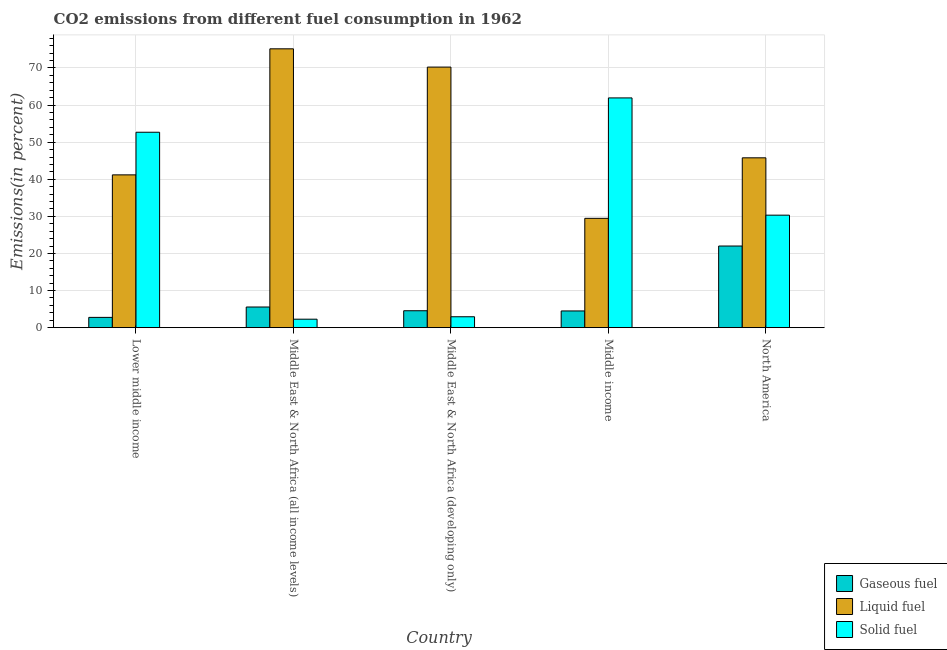How many groups of bars are there?
Your answer should be very brief. 5. Are the number of bars on each tick of the X-axis equal?
Give a very brief answer. Yes. How many bars are there on the 3rd tick from the left?
Provide a short and direct response. 3. What is the label of the 4th group of bars from the left?
Make the answer very short. Middle income. In how many cases, is the number of bars for a given country not equal to the number of legend labels?
Your answer should be compact. 0. What is the percentage of liquid fuel emission in Lower middle income?
Offer a terse response. 41.19. Across all countries, what is the maximum percentage of gaseous fuel emission?
Your answer should be very brief. 22. Across all countries, what is the minimum percentage of gaseous fuel emission?
Make the answer very short. 2.77. In which country was the percentage of solid fuel emission minimum?
Provide a short and direct response. Middle East & North Africa (all income levels). What is the total percentage of liquid fuel emission in the graph?
Offer a very short reply. 261.83. What is the difference between the percentage of solid fuel emission in Lower middle income and that in Middle East & North Africa (all income levels)?
Your response must be concise. 50.39. What is the difference between the percentage of liquid fuel emission in Middle income and the percentage of solid fuel emission in Middle East & North Africa (all income levels)?
Provide a succinct answer. 27.18. What is the average percentage of solid fuel emission per country?
Keep it short and to the point. 30.03. What is the difference between the percentage of solid fuel emission and percentage of gaseous fuel emission in Lower middle income?
Offer a very short reply. 49.9. What is the ratio of the percentage of solid fuel emission in Lower middle income to that in Middle income?
Offer a very short reply. 0.85. Is the difference between the percentage of solid fuel emission in Middle income and North America greater than the difference between the percentage of liquid fuel emission in Middle income and North America?
Keep it short and to the point. Yes. What is the difference between the highest and the second highest percentage of liquid fuel emission?
Your answer should be compact. 4.92. What is the difference between the highest and the lowest percentage of liquid fuel emission?
Your answer should be compact. 45.69. Is the sum of the percentage of liquid fuel emission in Lower middle income and Middle income greater than the maximum percentage of solid fuel emission across all countries?
Offer a very short reply. Yes. What does the 2nd bar from the left in Lower middle income represents?
Your answer should be very brief. Liquid fuel. What does the 2nd bar from the right in Middle income represents?
Your response must be concise. Liquid fuel. Is it the case that in every country, the sum of the percentage of gaseous fuel emission and percentage of liquid fuel emission is greater than the percentage of solid fuel emission?
Make the answer very short. No. What is the difference between two consecutive major ticks on the Y-axis?
Offer a very short reply. 10. Does the graph contain any zero values?
Ensure brevity in your answer.  No. Where does the legend appear in the graph?
Your answer should be very brief. Bottom right. How many legend labels are there?
Offer a very short reply. 3. What is the title of the graph?
Provide a succinct answer. CO2 emissions from different fuel consumption in 1962. Does "Ages 20-60" appear as one of the legend labels in the graph?
Your answer should be compact. No. What is the label or title of the X-axis?
Your answer should be compact. Country. What is the label or title of the Y-axis?
Keep it short and to the point. Emissions(in percent). What is the Emissions(in percent) in Gaseous fuel in Lower middle income?
Offer a terse response. 2.77. What is the Emissions(in percent) of Liquid fuel in Lower middle income?
Make the answer very short. 41.19. What is the Emissions(in percent) in Solid fuel in Lower middle income?
Your answer should be compact. 52.67. What is the Emissions(in percent) in Gaseous fuel in Middle East & North Africa (all income levels)?
Provide a succinct answer. 5.57. What is the Emissions(in percent) in Liquid fuel in Middle East & North Africa (all income levels)?
Your response must be concise. 75.16. What is the Emissions(in percent) of Solid fuel in Middle East & North Africa (all income levels)?
Keep it short and to the point. 2.28. What is the Emissions(in percent) of Gaseous fuel in Middle East & North Africa (developing only)?
Your response must be concise. 4.56. What is the Emissions(in percent) of Liquid fuel in Middle East & North Africa (developing only)?
Provide a short and direct response. 70.23. What is the Emissions(in percent) in Solid fuel in Middle East & North Africa (developing only)?
Give a very brief answer. 2.94. What is the Emissions(in percent) of Gaseous fuel in Middle income?
Provide a succinct answer. 4.5. What is the Emissions(in percent) in Liquid fuel in Middle income?
Your answer should be compact. 29.47. What is the Emissions(in percent) of Solid fuel in Middle income?
Provide a short and direct response. 61.92. What is the Emissions(in percent) in Gaseous fuel in North America?
Ensure brevity in your answer.  22. What is the Emissions(in percent) of Liquid fuel in North America?
Ensure brevity in your answer.  45.78. What is the Emissions(in percent) of Solid fuel in North America?
Your response must be concise. 30.32. Across all countries, what is the maximum Emissions(in percent) of Gaseous fuel?
Make the answer very short. 22. Across all countries, what is the maximum Emissions(in percent) of Liquid fuel?
Offer a very short reply. 75.16. Across all countries, what is the maximum Emissions(in percent) of Solid fuel?
Offer a terse response. 61.92. Across all countries, what is the minimum Emissions(in percent) in Gaseous fuel?
Provide a short and direct response. 2.77. Across all countries, what is the minimum Emissions(in percent) in Liquid fuel?
Provide a short and direct response. 29.47. Across all countries, what is the minimum Emissions(in percent) in Solid fuel?
Make the answer very short. 2.28. What is the total Emissions(in percent) of Gaseous fuel in the graph?
Give a very brief answer. 39.41. What is the total Emissions(in percent) of Liquid fuel in the graph?
Provide a succinct answer. 261.83. What is the total Emissions(in percent) of Solid fuel in the graph?
Your answer should be compact. 150.14. What is the difference between the Emissions(in percent) in Gaseous fuel in Lower middle income and that in Middle East & North Africa (all income levels)?
Your answer should be compact. -2.8. What is the difference between the Emissions(in percent) in Liquid fuel in Lower middle income and that in Middle East & North Africa (all income levels)?
Make the answer very short. -33.97. What is the difference between the Emissions(in percent) in Solid fuel in Lower middle income and that in Middle East & North Africa (all income levels)?
Make the answer very short. 50.39. What is the difference between the Emissions(in percent) of Gaseous fuel in Lower middle income and that in Middle East & North Africa (developing only)?
Provide a short and direct response. -1.79. What is the difference between the Emissions(in percent) of Liquid fuel in Lower middle income and that in Middle East & North Africa (developing only)?
Give a very brief answer. -29.05. What is the difference between the Emissions(in percent) in Solid fuel in Lower middle income and that in Middle East & North Africa (developing only)?
Ensure brevity in your answer.  49.73. What is the difference between the Emissions(in percent) of Gaseous fuel in Lower middle income and that in Middle income?
Keep it short and to the point. -1.73. What is the difference between the Emissions(in percent) in Liquid fuel in Lower middle income and that in Middle income?
Provide a succinct answer. 11.72. What is the difference between the Emissions(in percent) of Solid fuel in Lower middle income and that in Middle income?
Your answer should be compact. -9.25. What is the difference between the Emissions(in percent) of Gaseous fuel in Lower middle income and that in North America?
Your answer should be compact. -19.23. What is the difference between the Emissions(in percent) in Liquid fuel in Lower middle income and that in North America?
Provide a short and direct response. -4.59. What is the difference between the Emissions(in percent) of Solid fuel in Lower middle income and that in North America?
Offer a very short reply. 22.35. What is the difference between the Emissions(in percent) in Gaseous fuel in Middle East & North Africa (all income levels) and that in Middle East & North Africa (developing only)?
Ensure brevity in your answer.  1.01. What is the difference between the Emissions(in percent) in Liquid fuel in Middle East & North Africa (all income levels) and that in Middle East & North Africa (developing only)?
Provide a succinct answer. 4.92. What is the difference between the Emissions(in percent) in Solid fuel in Middle East & North Africa (all income levels) and that in Middle East & North Africa (developing only)?
Your answer should be compact. -0.65. What is the difference between the Emissions(in percent) of Gaseous fuel in Middle East & North Africa (all income levels) and that in Middle income?
Give a very brief answer. 1.06. What is the difference between the Emissions(in percent) of Liquid fuel in Middle East & North Africa (all income levels) and that in Middle income?
Provide a short and direct response. 45.69. What is the difference between the Emissions(in percent) of Solid fuel in Middle East & North Africa (all income levels) and that in Middle income?
Your answer should be very brief. -59.64. What is the difference between the Emissions(in percent) in Gaseous fuel in Middle East & North Africa (all income levels) and that in North America?
Give a very brief answer. -16.44. What is the difference between the Emissions(in percent) in Liquid fuel in Middle East & North Africa (all income levels) and that in North America?
Keep it short and to the point. 29.38. What is the difference between the Emissions(in percent) in Solid fuel in Middle East & North Africa (all income levels) and that in North America?
Ensure brevity in your answer.  -28.04. What is the difference between the Emissions(in percent) in Gaseous fuel in Middle East & North Africa (developing only) and that in Middle income?
Keep it short and to the point. 0.06. What is the difference between the Emissions(in percent) in Liquid fuel in Middle East & North Africa (developing only) and that in Middle income?
Offer a terse response. 40.77. What is the difference between the Emissions(in percent) in Solid fuel in Middle East & North Africa (developing only) and that in Middle income?
Offer a very short reply. -58.99. What is the difference between the Emissions(in percent) in Gaseous fuel in Middle East & North Africa (developing only) and that in North America?
Offer a very short reply. -17.44. What is the difference between the Emissions(in percent) in Liquid fuel in Middle East & North Africa (developing only) and that in North America?
Your response must be concise. 24.46. What is the difference between the Emissions(in percent) of Solid fuel in Middle East & North Africa (developing only) and that in North America?
Give a very brief answer. -27.38. What is the difference between the Emissions(in percent) in Gaseous fuel in Middle income and that in North America?
Offer a terse response. -17.5. What is the difference between the Emissions(in percent) in Liquid fuel in Middle income and that in North America?
Provide a short and direct response. -16.31. What is the difference between the Emissions(in percent) of Solid fuel in Middle income and that in North America?
Your answer should be very brief. 31.6. What is the difference between the Emissions(in percent) in Gaseous fuel in Lower middle income and the Emissions(in percent) in Liquid fuel in Middle East & North Africa (all income levels)?
Keep it short and to the point. -72.39. What is the difference between the Emissions(in percent) in Gaseous fuel in Lower middle income and the Emissions(in percent) in Solid fuel in Middle East & North Africa (all income levels)?
Your answer should be very brief. 0.49. What is the difference between the Emissions(in percent) in Liquid fuel in Lower middle income and the Emissions(in percent) in Solid fuel in Middle East & North Africa (all income levels)?
Your answer should be compact. 38.9. What is the difference between the Emissions(in percent) of Gaseous fuel in Lower middle income and the Emissions(in percent) of Liquid fuel in Middle East & North Africa (developing only)?
Make the answer very short. -67.46. What is the difference between the Emissions(in percent) of Gaseous fuel in Lower middle income and the Emissions(in percent) of Solid fuel in Middle East & North Africa (developing only)?
Ensure brevity in your answer.  -0.17. What is the difference between the Emissions(in percent) in Liquid fuel in Lower middle income and the Emissions(in percent) in Solid fuel in Middle East & North Africa (developing only)?
Give a very brief answer. 38.25. What is the difference between the Emissions(in percent) of Gaseous fuel in Lower middle income and the Emissions(in percent) of Liquid fuel in Middle income?
Offer a terse response. -26.7. What is the difference between the Emissions(in percent) of Gaseous fuel in Lower middle income and the Emissions(in percent) of Solid fuel in Middle income?
Offer a terse response. -59.15. What is the difference between the Emissions(in percent) of Liquid fuel in Lower middle income and the Emissions(in percent) of Solid fuel in Middle income?
Provide a succinct answer. -20.74. What is the difference between the Emissions(in percent) of Gaseous fuel in Lower middle income and the Emissions(in percent) of Liquid fuel in North America?
Give a very brief answer. -43.01. What is the difference between the Emissions(in percent) of Gaseous fuel in Lower middle income and the Emissions(in percent) of Solid fuel in North America?
Give a very brief answer. -27.55. What is the difference between the Emissions(in percent) in Liquid fuel in Lower middle income and the Emissions(in percent) in Solid fuel in North America?
Offer a terse response. 10.86. What is the difference between the Emissions(in percent) of Gaseous fuel in Middle East & North Africa (all income levels) and the Emissions(in percent) of Liquid fuel in Middle East & North Africa (developing only)?
Your response must be concise. -64.67. What is the difference between the Emissions(in percent) of Gaseous fuel in Middle East & North Africa (all income levels) and the Emissions(in percent) of Solid fuel in Middle East & North Africa (developing only)?
Offer a very short reply. 2.63. What is the difference between the Emissions(in percent) of Liquid fuel in Middle East & North Africa (all income levels) and the Emissions(in percent) of Solid fuel in Middle East & North Africa (developing only)?
Your answer should be very brief. 72.22. What is the difference between the Emissions(in percent) in Gaseous fuel in Middle East & North Africa (all income levels) and the Emissions(in percent) in Liquid fuel in Middle income?
Give a very brief answer. -23.9. What is the difference between the Emissions(in percent) of Gaseous fuel in Middle East & North Africa (all income levels) and the Emissions(in percent) of Solid fuel in Middle income?
Your response must be concise. -56.36. What is the difference between the Emissions(in percent) in Liquid fuel in Middle East & North Africa (all income levels) and the Emissions(in percent) in Solid fuel in Middle income?
Make the answer very short. 13.23. What is the difference between the Emissions(in percent) of Gaseous fuel in Middle East & North Africa (all income levels) and the Emissions(in percent) of Liquid fuel in North America?
Provide a succinct answer. -40.21. What is the difference between the Emissions(in percent) in Gaseous fuel in Middle East & North Africa (all income levels) and the Emissions(in percent) in Solid fuel in North America?
Offer a very short reply. -24.75. What is the difference between the Emissions(in percent) of Liquid fuel in Middle East & North Africa (all income levels) and the Emissions(in percent) of Solid fuel in North America?
Ensure brevity in your answer.  44.84. What is the difference between the Emissions(in percent) in Gaseous fuel in Middle East & North Africa (developing only) and the Emissions(in percent) in Liquid fuel in Middle income?
Provide a succinct answer. -24.91. What is the difference between the Emissions(in percent) in Gaseous fuel in Middle East & North Africa (developing only) and the Emissions(in percent) in Solid fuel in Middle income?
Give a very brief answer. -57.36. What is the difference between the Emissions(in percent) in Liquid fuel in Middle East & North Africa (developing only) and the Emissions(in percent) in Solid fuel in Middle income?
Provide a succinct answer. 8.31. What is the difference between the Emissions(in percent) in Gaseous fuel in Middle East & North Africa (developing only) and the Emissions(in percent) in Liquid fuel in North America?
Give a very brief answer. -41.22. What is the difference between the Emissions(in percent) of Gaseous fuel in Middle East & North Africa (developing only) and the Emissions(in percent) of Solid fuel in North America?
Ensure brevity in your answer.  -25.76. What is the difference between the Emissions(in percent) in Liquid fuel in Middle East & North Africa (developing only) and the Emissions(in percent) in Solid fuel in North America?
Provide a succinct answer. 39.91. What is the difference between the Emissions(in percent) in Gaseous fuel in Middle income and the Emissions(in percent) in Liquid fuel in North America?
Offer a very short reply. -41.27. What is the difference between the Emissions(in percent) of Gaseous fuel in Middle income and the Emissions(in percent) of Solid fuel in North America?
Offer a terse response. -25.82. What is the difference between the Emissions(in percent) in Liquid fuel in Middle income and the Emissions(in percent) in Solid fuel in North America?
Offer a very short reply. -0.85. What is the average Emissions(in percent) of Gaseous fuel per country?
Keep it short and to the point. 7.88. What is the average Emissions(in percent) of Liquid fuel per country?
Offer a terse response. 52.37. What is the average Emissions(in percent) in Solid fuel per country?
Your answer should be very brief. 30.03. What is the difference between the Emissions(in percent) of Gaseous fuel and Emissions(in percent) of Liquid fuel in Lower middle income?
Provide a succinct answer. -38.41. What is the difference between the Emissions(in percent) of Gaseous fuel and Emissions(in percent) of Solid fuel in Lower middle income?
Offer a very short reply. -49.9. What is the difference between the Emissions(in percent) in Liquid fuel and Emissions(in percent) in Solid fuel in Lower middle income?
Offer a very short reply. -11.49. What is the difference between the Emissions(in percent) of Gaseous fuel and Emissions(in percent) of Liquid fuel in Middle East & North Africa (all income levels)?
Your answer should be very brief. -69.59. What is the difference between the Emissions(in percent) of Gaseous fuel and Emissions(in percent) of Solid fuel in Middle East & North Africa (all income levels)?
Your answer should be compact. 3.28. What is the difference between the Emissions(in percent) of Liquid fuel and Emissions(in percent) of Solid fuel in Middle East & North Africa (all income levels)?
Ensure brevity in your answer.  72.88. What is the difference between the Emissions(in percent) in Gaseous fuel and Emissions(in percent) in Liquid fuel in Middle East & North Africa (developing only)?
Your response must be concise. -65.67. What is the difference between the Emissions(in percent) in Gaseous fuel and Emissions(in percent) in Solid fuel in Middle East & North Africa (developing only)?
Offer a very short reply. 1.62. What is the difference between the Emissions(in percent) of Liquid fuel and Emissions(in percent) of Solid fuel in Middle East & North Africa (developing only)?
Provide a succinct answer. 67.3. What is the difference between the Emissions(in percent) of Gaseous fuel and Emissions(in percent) of Liquid fuel in Middle income?
Provide a short and direct response. -24.96. What is the difference between the Emissions(in percent) in Gaseous fuel and Emissions(in percent) in Solid fuel in Middle income?
Offer a very short reply. -57.42. What is the difference between the Emissions(in percent) of Liquid fuel and Emissions(in percent) of Solid fuel in Middle income?
Give a very brief answer. -32.46. What is the difference between the Emissions(in percent) in Gaseous fuel and Emissions(in percent) in Liquid fuel in North America?
Offer a terse response. -23.77. What is the difference between the Emissions(in percent) in Gaseous fuel and Emissions(in percent) in Solid fuel in North America?
Make the answer very short. -8.32. What is the difference between the Emissions(in percent) in Liquid fuel and Emissions(in percent) in Solid fuel in North America?
Provide a succinct answer. 15.46. What is the ratio of the Emissions(in percent) of Gaseous fuel in Lower middle income to that in Middle East & North Africa (all income levels)?
Offer a very short reply. 0.5. What is the ratio of the Emissions(in percent) in Liquid fuel in Lower middle income to that in Middle East & North Africa (all income levels)?
Your answer should be compact. 0.55. What is the ratio of the Emissions(in percent) of Solid fuel in Lower middle income to that in Middle East & North Africa (all income levels)?
Make the answer very short. 23.07. What is the ratio of the Emissions(in percent) in Gaseous fuel in Lower middle income to that in Middle East & North Africa (developing only)?
Your answer should be compact. 0.61. What is the ratio of the Emissions(in percent) of Liquid fuel in Lower middle income to that in Middle East & North Africa (developing only)?
Provide a short and direct response. 0.59. What is the ratio of the Emissions(in percent) of Solid fuel in Lower middle income to that in Middle East & North Africa (developing only)?
Keep it short and to the point. 17.93. What is the ratio of the Emissions(in percent) of Gaseous fuel in Lower middle income to that in Middle income?
Provide a succinct answer. 0.62. What is the ratio of the Emissions(in percent) in Liquid fuel in Lower middle income to that in Middle income?
Make the answer very short. 1.4. What is the ratio of the Emissions(in percent) in Solid fuel in Lower middle income to that in Middle income?
Your response must be concise. 0.85. What is the ratio of the Emissions(in percent) of Gaseous fuel in Lower middle income to that in North America?
Offer a very short reply. 0.13. What is the ratio of the Emissions(in percent) of Liquid fuel in Lower middle income to that in North America?
Your response must be concise. 0.9. What is the ratio of the Emissions(in percent) of Solid fuel in Lower middle income to that in North America?
Your answer should be very brief. 1.74. What is the ratio of the Emissions(in percent) of Gaseous fuel in Middle East & North Africa (all income levels) to that in Middle East & North Africa (developing only)?
Provide a succinct answer. 1.22. What is the ratio of the Emissions(in percent) of Liquid fuel in Middle East & North Africa (all income levels) to that in Middle East & North Africa (developing only)?
Offer a terse response. 1.07. What is the ratio of the Emissions(in percent) of Solid fuel in Middle East & North Africa (all income levels) to that in Middle East & North Africa (developing only)?
Keep it short and to the point. 0.78. What is the ratio of the Emissions(in percent) in Gaseous fuel in Middle East & North Africa (all income levels) to that in Middle income?
Make the answer very short. 1.24. What is the ratio of the Emissions(in percent) in Liquid fuel in Middle East & North Africa (all income levels) to that in Middle income?
Provide a short and direct response. 2.55. What is the ratio of the Emissions(in percent) in Solid fuel in Middle East & North Africa (all income levels) to that in Middle income?
Your answer should be very brief. 0.04. What is the ratio of the Emissions(in percent) of Gaseous fuel in Middle East & North Africa (all income levels) to that in North America?
Offer a terse response. 0.25. What is the ratio of the Emissions(in percent) of Liquid fuel in Middle East & North Africa (all income levels) to that in North America?
Make the answer very short. 1.64. What is the ratio of the Emissions(in percent) of Solid fuel in Middle East & North Africa (all income levels) to that in North America?
Keep it short and to the point. 0.08. What is the ratio of the Emissions(in percent) of Gaseous fuel in Middle East & North Africa (developing only) to that in Middle income?
Make the answer very short. 1.01. What is the ratio of the Emissions(in percent) in Liquid fuel in Middle East & North Africa (developing only) to that in Middle income?
Provide a succinct answer. 2.38. What is the ratio of the Emissions(in percent) of Solid fuel in Middle East & North Africa (developing only) to that in Middle income?
Offer a very short reply. 0.05. What is the ratio of the Emissions(in percent) of Gaseous fuel in Middle East & North Africa (developing only) to that in North America?
Offer a very short reply. 0.21. What is the ratio of the Emissions(in percent) of Liquid fuel in Middle East & North Africa (developing only) to that in North America?
Make the answer very short. 1.53. What is the ratio of the Emissions(in percent) in Solid fuel in Middle East & North Africa (developing only) to that in North America?
Make the answer very short. 0.1. What is the ratio of the Emissions(in percent) of Gaseous fuel in Middle income to that in North America?
Ensure brevity in your answer.  0.2. What is the ratio of the Emissions(in percent) in Liquid fuel in Middle income to that in North America?
Provide a short and direct response. 0.64. What is the ratio of the Emissions(in percent) in Solid fuel in Middle income to that in North America?
Offer a very short reply. 2.04. What is the difference between the highest and the second highest Emissions(in percent) in Gaseous fuel?
Keep it short and to the point. 16.44. What is the difference between the highest and the second highest Emissions(in percent) of Liquid fuel?
Provide a short and direct response. 4.92. What is the difference between the highest and the second highest Emissions(in percent) of Solid fuel?
Offer a terse response. 9.25. What is the difference between the highest and the lowest Emissions(in percent) in Gaseous fuel?
Provide a short and direct response. 19.23. What is the difference between the highest and the lowest Emissions(in percent) in Liquid fuel?
Provide a short and direct response. 45.69. What is the difference between the highest and the lowest Emissions(in percent) in Solid fuel?
Your answer should be compact. 59.64. 